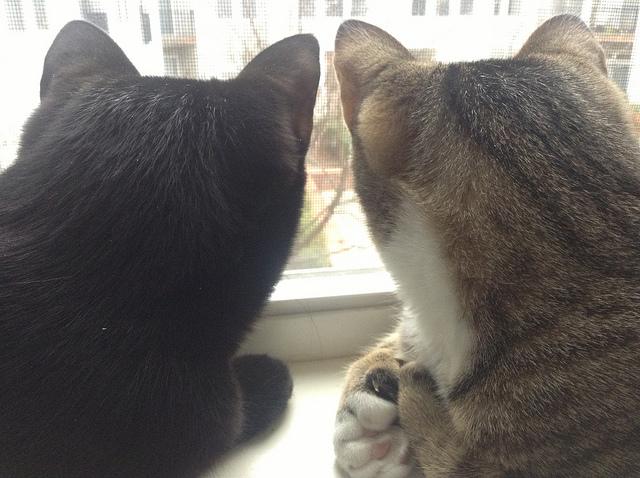What are the cats doing?
Answer briefly. Looking out window. Are the cats curious?
Keep it brief. Yes. How many cats are there?
Short answer required. 2. 